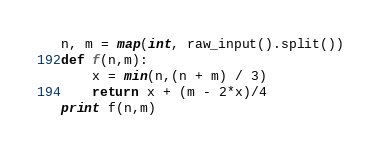<code> <loc_0><loc_0><loc_500><loc_500><_Python_>n, m = map(int, raw_input().split())
def f(n,m): 
	x = min(n,(n + m) / 3)
	return x + (m - 2*x)/4
print f(n,m)</code> 